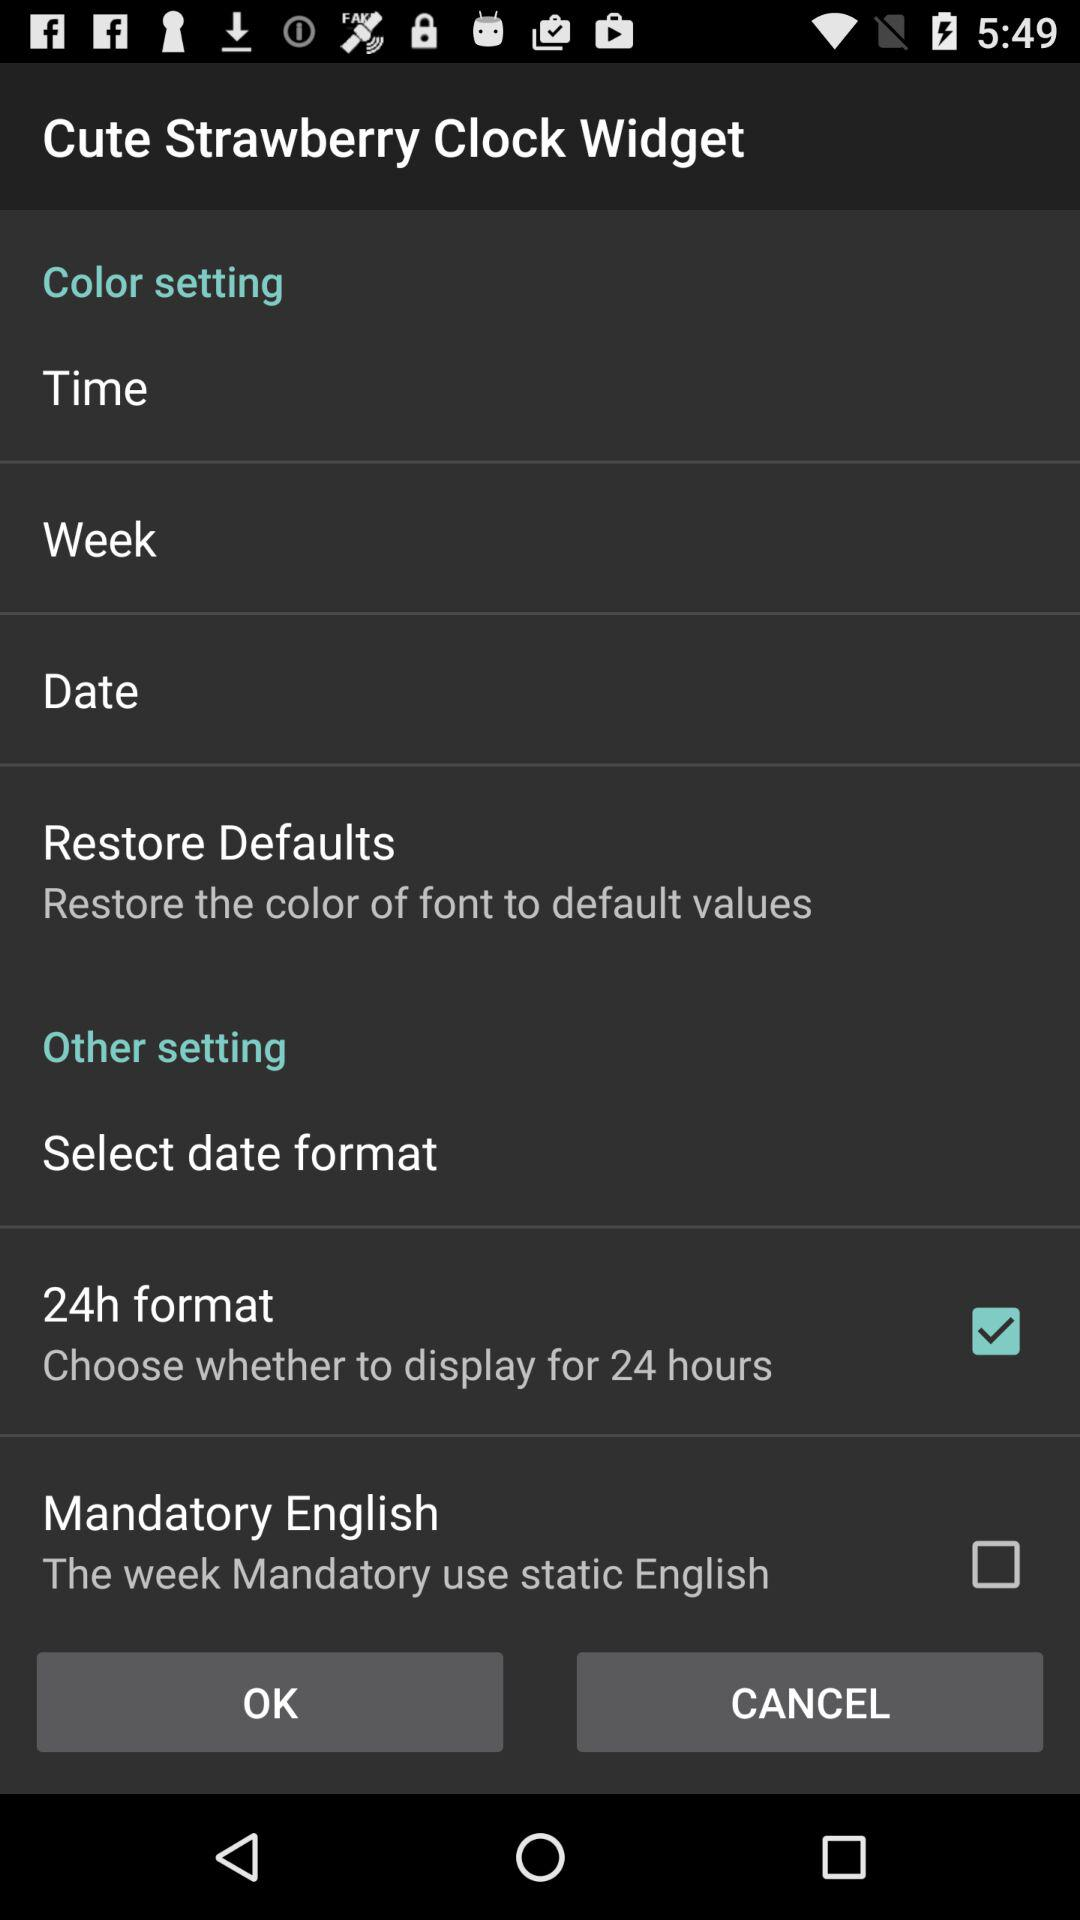What is the status of "Mandatory English"? The status is "off". 